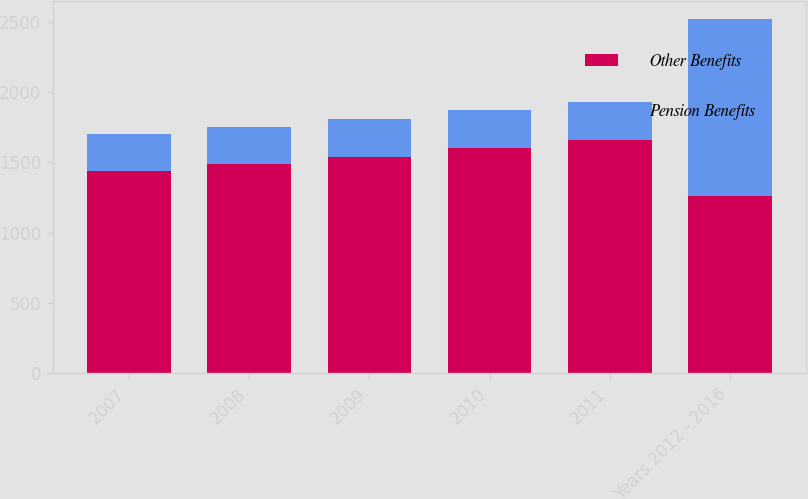<chart> <loc_0><loc_0><loc_500><loc_500><stacked_bar_chart><ecel><fcel>2007<fcel>2008<fcel>2009<fcel>2010<fcel>2011<fcel>Years 2012 - 2016<nl><fcel>Other Benefits<fcel>1440<fcel>1490<fcel>1540<fcel>1600<fcel>1660<fcel>1260<nl><fcel>Pension Benefits<fcel>260<fcel>260<fcel>270<fcel>270<fcel>270<fcel>1260<nl></chart> 